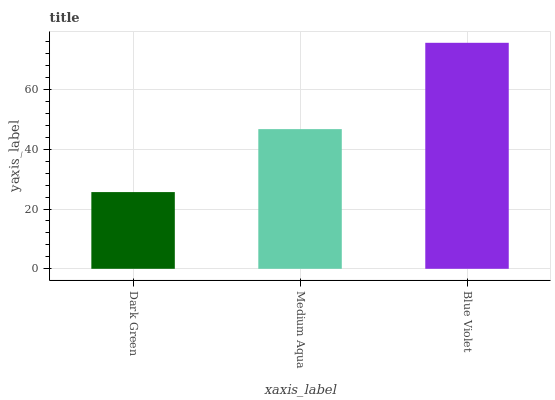Is Dark Green the minimum?
Answer yes or no. Yes. Is Blue Violet the maximum?
Answer yes or no. Yes. Is Medium Aqua the minimum?
Answer yes or no. No. Is Medium Aqua the maximum?
Answer yes or no. No. Is Medium Aqua greater than Dark Green?
Answer yes or no. Yes. Is Dark Green less than Medium Aqua?
Answer yes or no. Yes. Is Dark Green greater than Medium Aqua?
Answer yes or no. No. Is Medium Aqua less than Dark Green?
Answer yes or no. No. Is Medium Aqua the high median?
Answer yes or no. Yes. Is Medium Aqua the low median?
Answer yes or no. Yes. Is Dark Green the high median?
Answer yes or no. No. Is Blue Violet the low median?
Answer yes or no. No. 